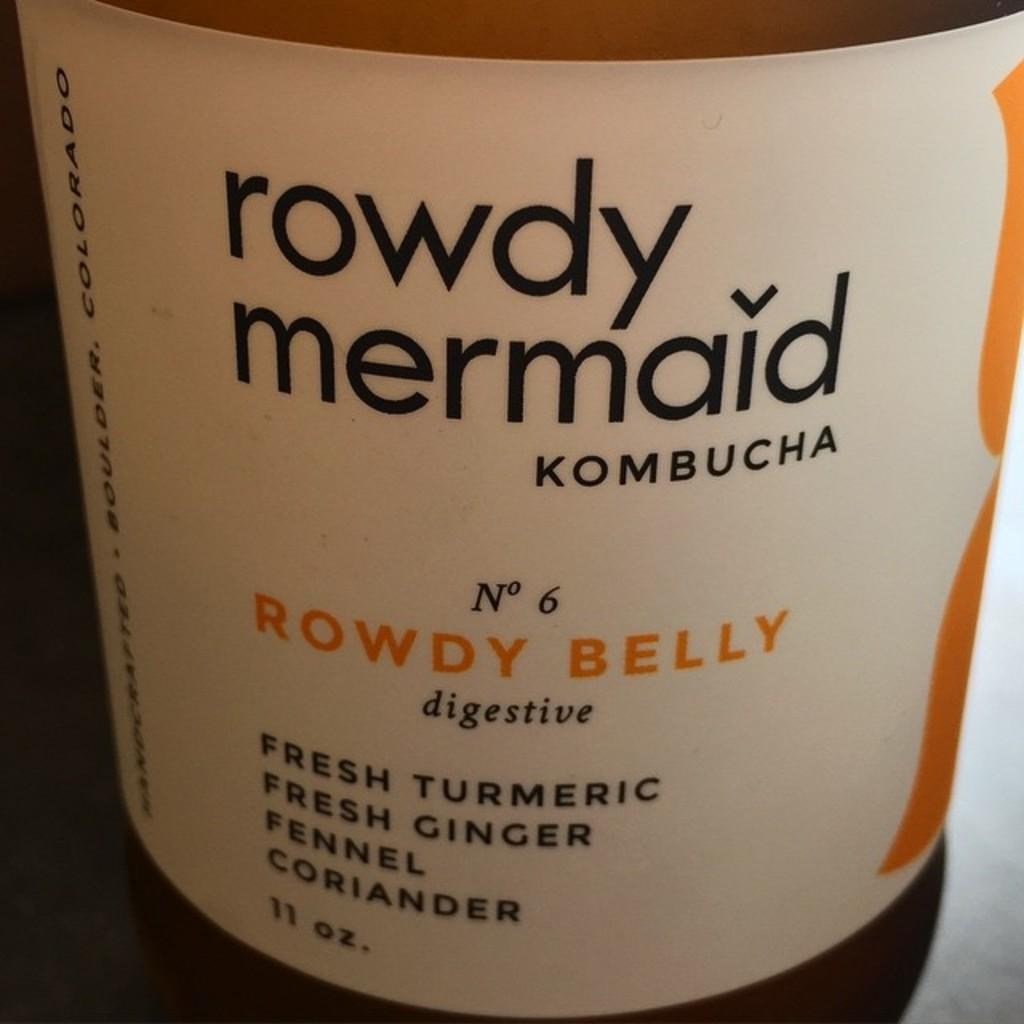<image>
Offer a succinct explanation of the picture presented. A label for rowdy mermaid KOMBUCHA No 6 ROWDY BELLY, 